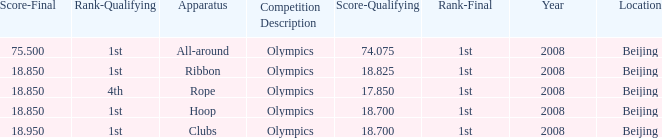On which device did kanayeva obtain a final score less than 7 Rope. 